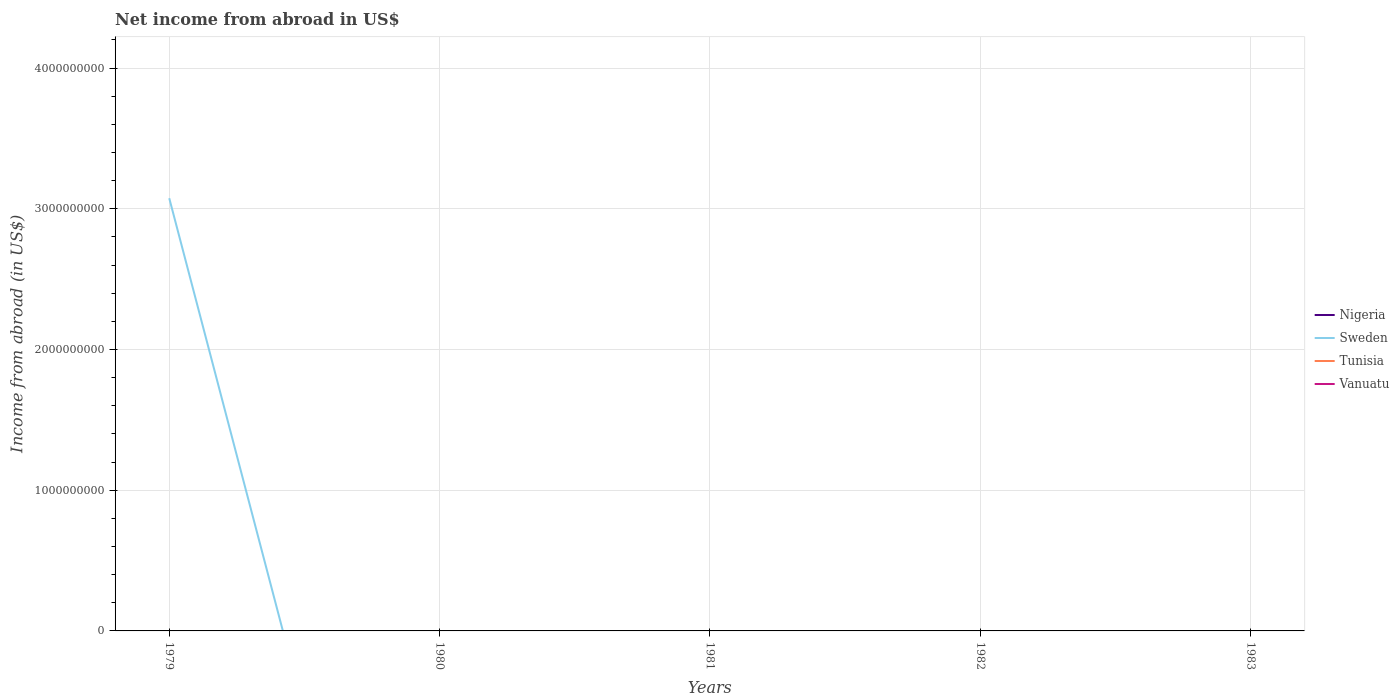How many different coloured lines are there?
Make the answer very short. 1. Does the line corresponding to Vanuatu intersect with the line corresponding to Sweden?
Your answer should be compact. Yes. What is the difference between the highest and the second highest net income from abroad in Sweden?
Your answer should be very brief. 3.08e+09. What is the difference between the highest and the lowest net income from abroad in Tunisia?
Your answer should be compact. 0. Is the net income from abroad in Tunisia strictly greater than the net income from abroad in Sweden over the years?
Provide a short and direct response. No. How many lines are there?
Make the answer very short. 1. How many years are there in the graph?
Make the answer very short. 5. What is the difference between two consecutive major ticks on the Y-axis?
Make the answer very short. 1.00e+09. Are the values on the major ticks of Y-axis written in scientific E-notation?
Provide a succinct answer. No. How are the legend labels stacked?
Provide a short and direct response. Vertical. What is the title of the graph?
Give a very brief answer. Net income from abroad in US$. Does "Middle income" appear as one of the legend labels in the graph?
Provide a succinct answer. No. What is the label or title of the X-axis?
Provide a succinct answer. Years. What is the label or title of the Y-axis?
Your answer should be compact. Income from abroad (in US$). What is the Income from abroad (in US$) of Sweden in 1979?
Your answer should be compact. 3.08e+09. What is the Income from abroad (in US$) in Tunisia in 1979?
Your answer should be very brief. 0. What is the Income from abroad (in US$) of Vanuatu in 1979?
Your answer should be compact. 0. What is the Income from abroad (in US$) of Nigeria in 1980?
Provide a short and direct response. 0. What is the Income from abroad (in US$) of Tunisia in 1980?
Ensure brevity in your answer.  0. What is the Income from abroad (in US$) in Vanuatu in 1980?
Provide a short and direct response. 0. What is the Income from abroad (in US$) in Nigeria in 1981?
Ensure brevity in your answer.  0. What is the Income from abroad (in US$) of Sweden in 1981?
Make the answer very short. 0. What is the Income from abroad (in US$) in Vanuatu in 1981?
Your answer should be compact. 0. What is the Income from abroad (in US$) in Vanuatu in 1982?
Your answer should be compact. 0. What is the Income from abroad (in US$) of Nigeria in 1983?
Ensure brevity in your answer.  0. Across all years, what is the maximum Income from abroad (in US$) of Sweden?
Offer a terse response. 3.08e+09. Across all years, what is the minimum Income from abroad (in US$) in Sweden?
Keep it short and to the point. 0. What is the total Income from abroad (in US$) of Nigeria in the graph?
Give a very brief answer. 0. What is the total Income from abroad (in US$) of Sweden in the graph?
Offer a very short reply. 3.08e+09. What is the average Income from abroad (in US$) in Sweden per year?
Your response must be concise. 6.15e+08. What is the difference between the highest and the lowest Income from abroad (in US$) in Sweden?
Offer a terse response. 3.08e+09. 